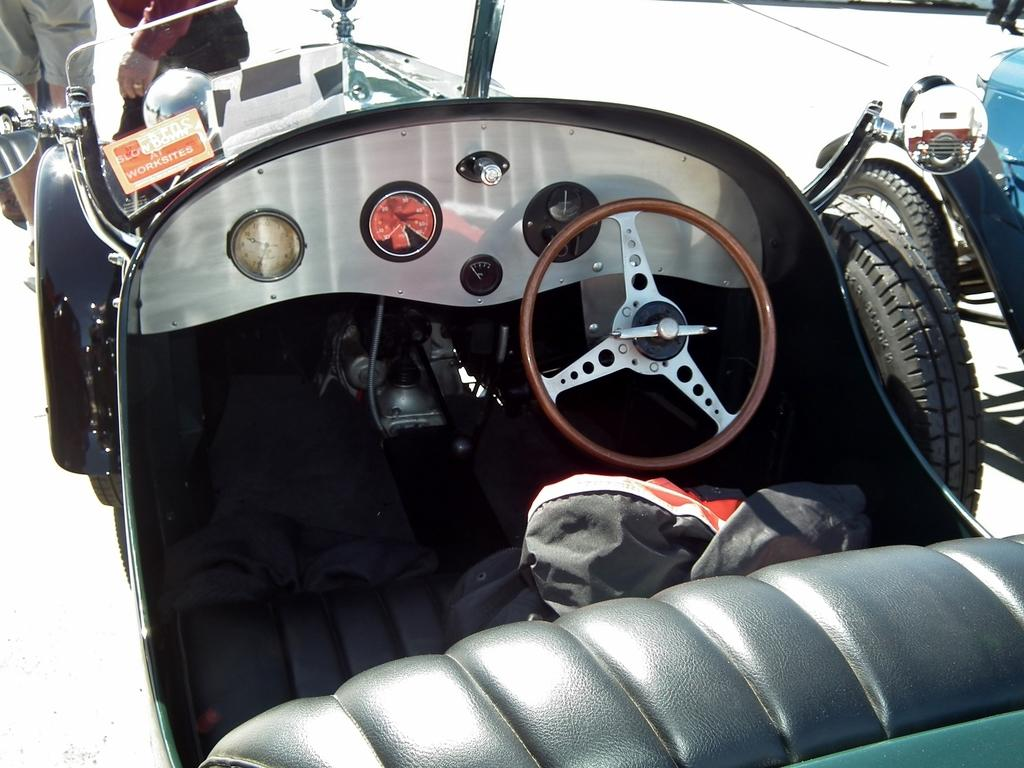What is the main subject of the image? The image shows the inner part of a vehicle. What can be seen in the front of the vehicle? The steering wheel is visible in the image. Are there any people present in the image? Yes, there are two persons standing in the background of the image. What type of home can be seen in the background of the image? There is no home visible in the background of the image; it shows the interior of a vehicle. Are the two persons swimming in the image? There is no indication of swimming or any water-related activity in the image. 